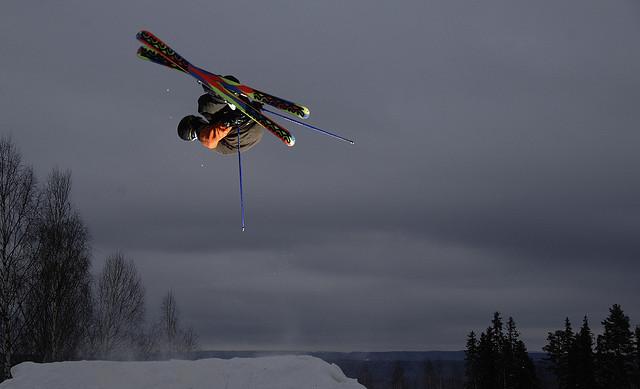What did the skier go off of?
Answer briefly. Ramp. What is the man doing?
Concise answer only. Skiing. What is the boy riding on?
Answer briefly. Skis. Is the man on air?
Keep it brief. Yes. What is on their feet?
Answer briefly. Skis. What winter sport is happening?
Give a very brief answer. Skiing. What color are his skis?
Keep it brief. Black. What color is the sky?
Keep it brief. Gray. Is it sunny outside?
Answer briefly. No. 